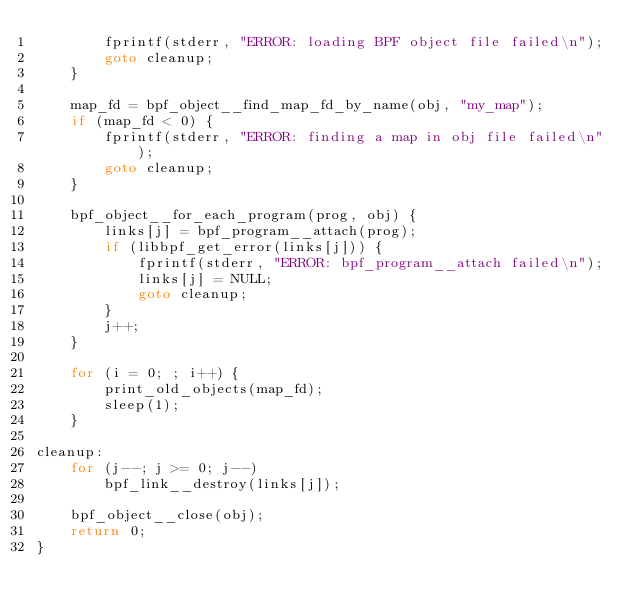Convert code to text. <code><loc_0><loc_0><loc_500><loc_500><_C_>		fprintf(stderr, "ERROR: loading BPF object file failed\n");
		goto cleanup;
	}

	map_fd = bpf_object__find_map_fd_by_name(obj, "my_map");
	if (map_fd < 0) {
		fprintf(stderr, "ERROR: finding a map in obj file failed\n");
		goto cleanup;
	}

	bpf_object__for_each_program(prog, obj) {
		links[j] = bpf_program__attach(prog);
		if (libbpf_get_error(links[j])) {
			fprintf(stderr, "ERROR: bpf_program__attach failed\n");
			links[j] = NULL;
			goto cleanup;
		}
		j++;
	}

	for (i = 0; ; i++) {
		print_old_objects(map_fd);
		sleep(1);
	}

cleanup:
	for (j--; j >= 0; j--)
		bpf_link__destroy(links[j]);

	bpf_object__close(obj);
	return 0;
}
</code> 